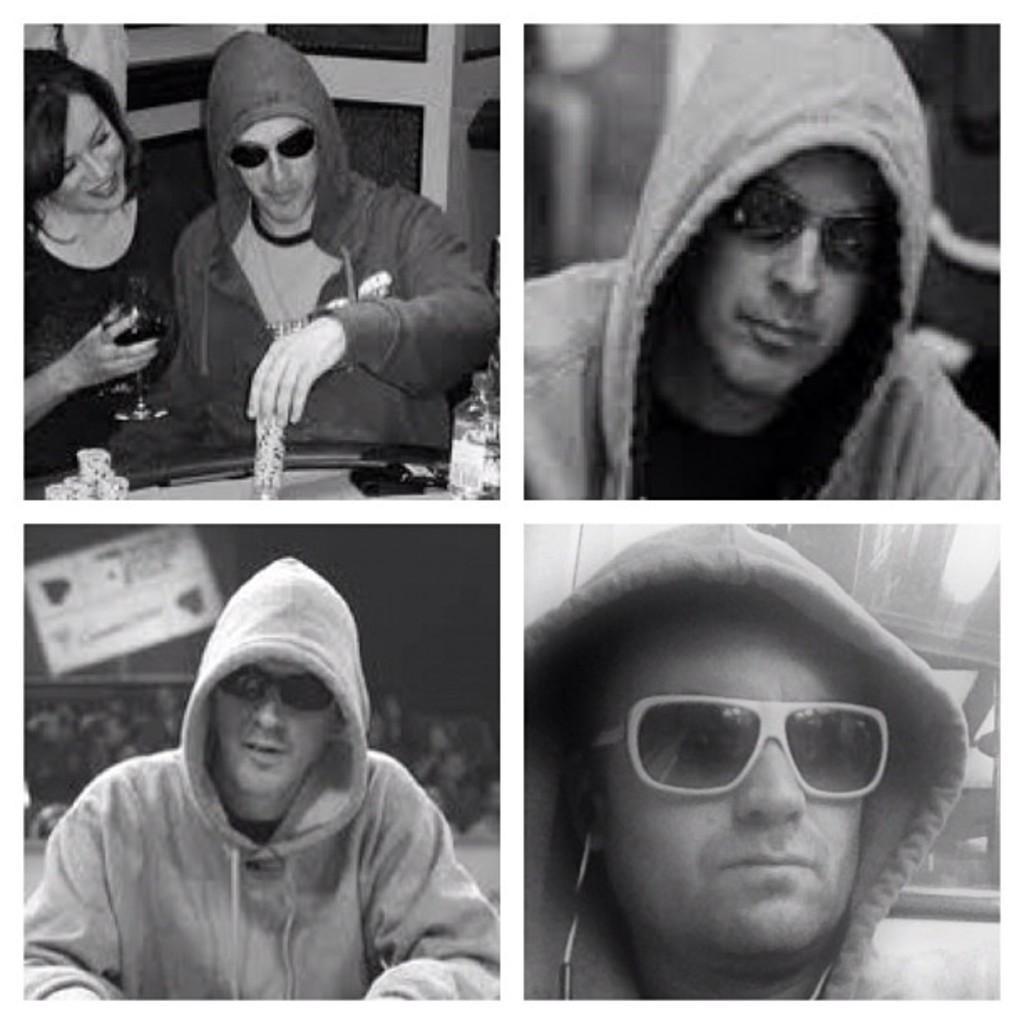Please provide a concise description of this image. In this image I can see the collage image. I can see few people and one person is holding the glass. The image is in black and white. 